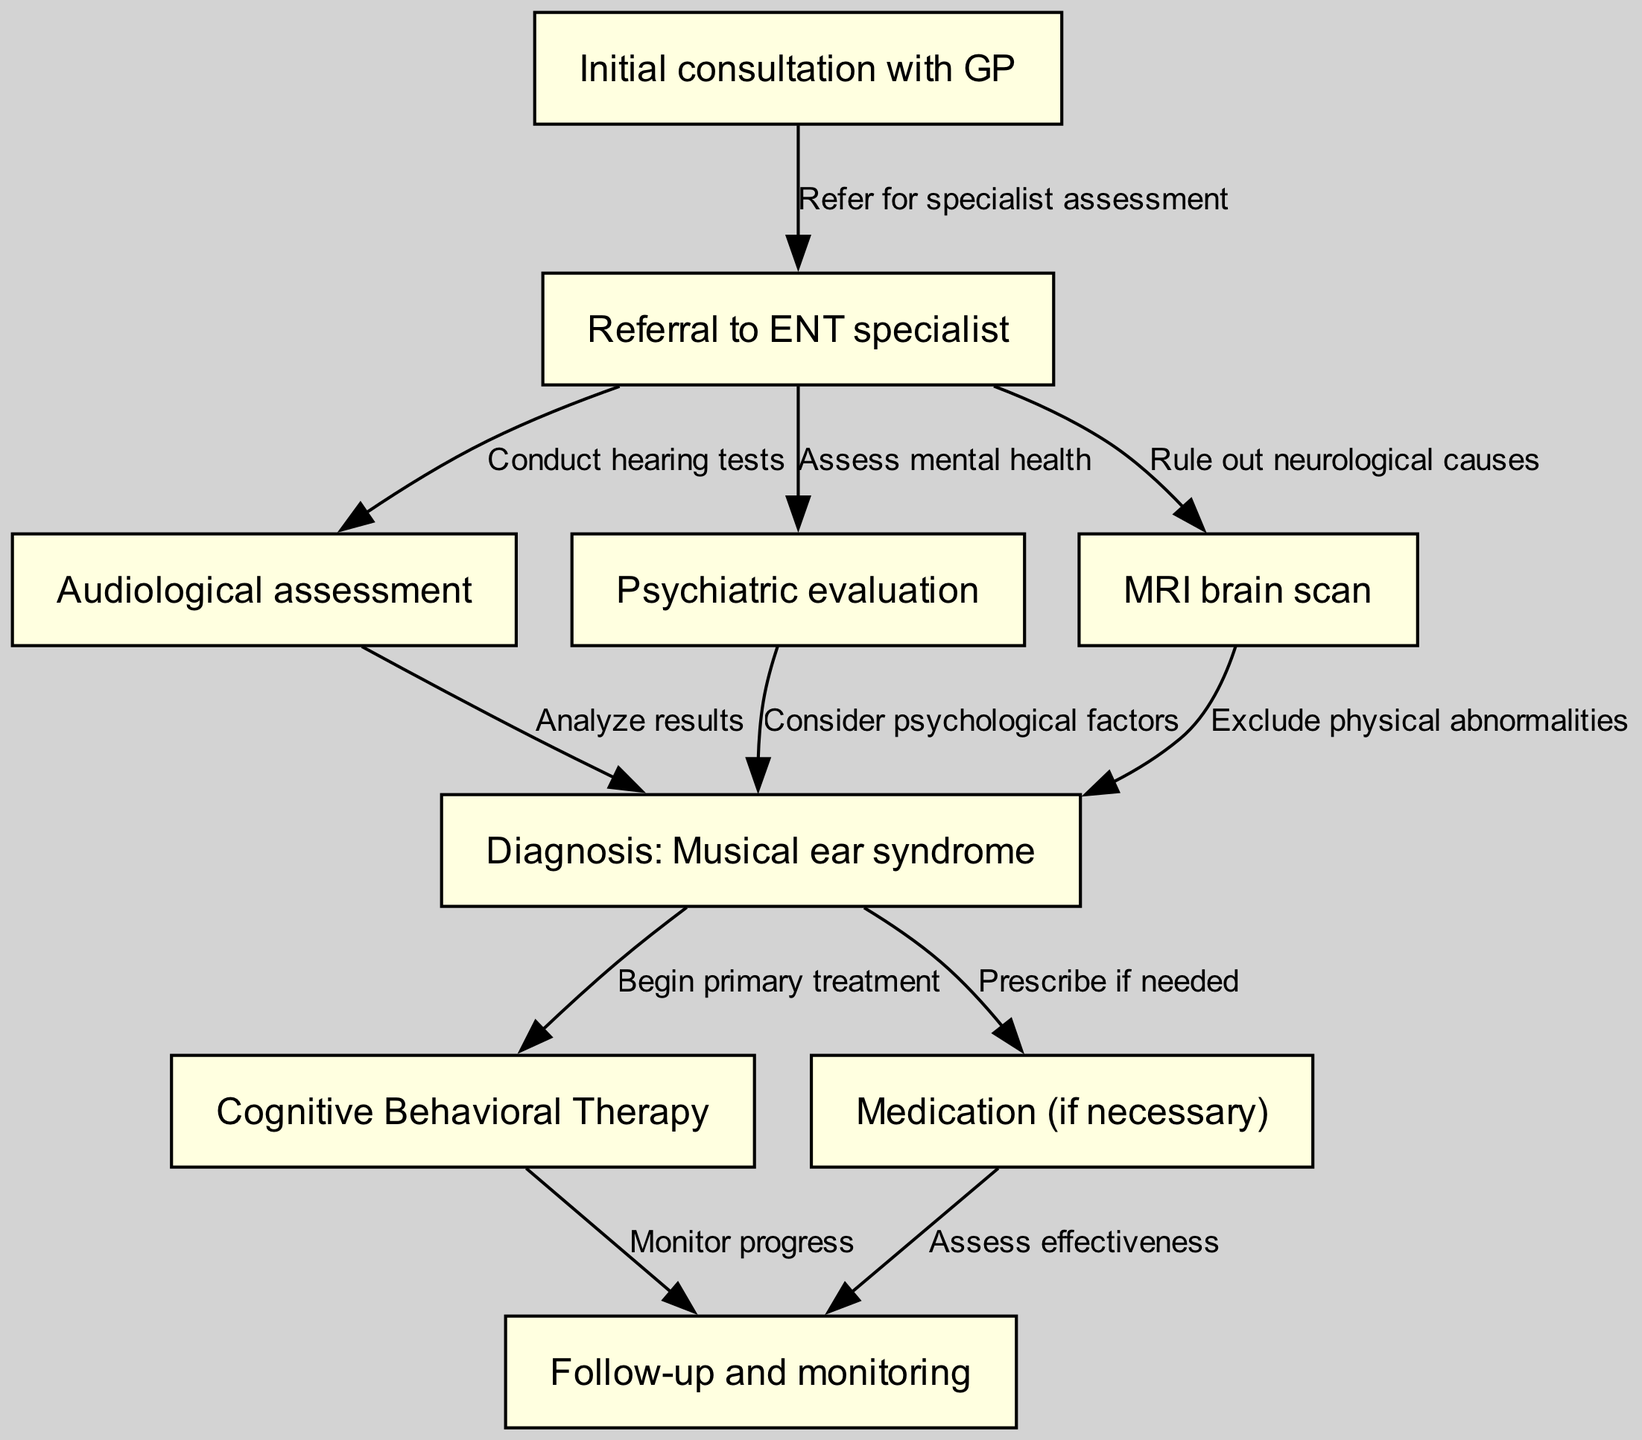What is the first step in the clinical pathway? The diagram shows that the first step is labeled as "Initial consultation with GP," which is the starting point of the pathway.
Answer: Initial consultation with GP How many nodes are in the diagram? By counting the nodes listed, there are a total of nine distinct nodes represented in the diagram.
Answer: 9 What is the diagnosis made after assessments? The diagram indicates the diagnosis made after the assessment is "Musical ear syndrome."
Answer: Musical ear syndrome Which node leads to the assessment of mental health? The edge from the "Referral to ENT specialist" node shows that it leads to the "Psychiatric evaluation," indicating assessments of mental health occur here.
Answer: Psychiatric evaluation What is one primary treatment option following the diagnosis? The "Cognitive Behavioral Therapy" node directly follows the diagnosis of "Musical ear syndrome," indicating this is one of the primary treatment options.
Answer: Cognitive Behavioral Therapy What is assessed after the medication is prescribed? The flow diagram specifies that follow-up and monitoring occur after the medication has been prescribed, reflecting the evaluation of treatment effectiveness.
Answer: Assess effectiveness How many edges are there from the "Referral to ENT specialist" node? The diagram shows three edges originating from the "Referral to ENT specialist" node, indicating multiple pathways for further assessment.
Answer: 3 What is a necessary step to rule out neurological causes? According to the diagram, the step involved in ruling out neurological causes is the "MRI brain scan," which takes place after the referral.
Answer: MRI brain scan What happens after beginning the primary treatment? The "Follow-up and monitoring" follows the "Cognitive Behavioral Therapy," indicating the subsequent action taken after starting treatment.
Answer: Monitor progress 